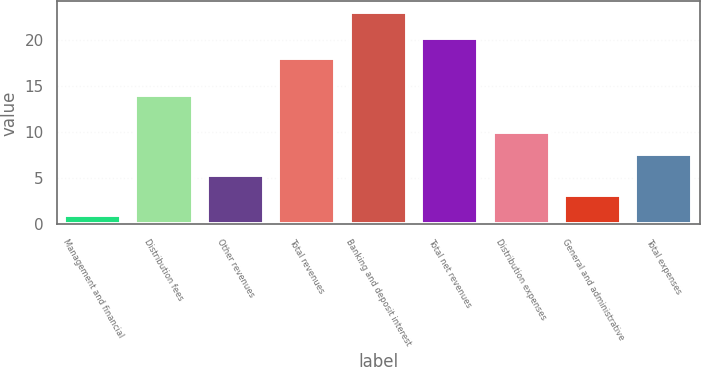Convert chart. <chart><loc_0><loc_0><loc_500><loc_500><bar_chart><fcel>Management and financial<fcel>Distribution fees<fcel>Other revenues<fcel>Total revenues<fcel>Banking and deposit interest<fcel>Total net revenues<fcel>Distribution expenses<fcel>General and administrative<fcel>Total expenses<nl><fcel>1<fcel>14<fcel>5.4<fcel>18<fcel>23<fcel>20.2<fcel>10<fcel>3.2<fcel>7.6<nl></chart> 